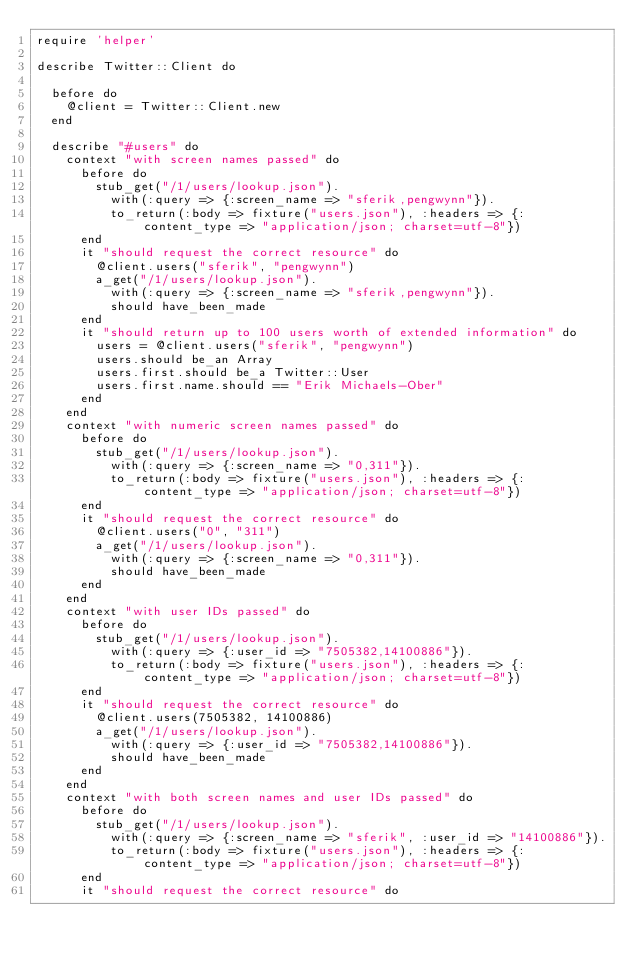<code> <loc_0><loc_0><loc_500><loc_500><_Ruby_>require 'helper'

describe Twitter::Client do

  before do
    @client = Twitter::Client.new
  end

  describe "#users" do
    context "with screen names passed" do
      before do
        stub_get("/1/users/lookup.json").
          with(:query => {:screen_name => "sferik,pengwynn"}).
          to_return(:body => fixture("users.json"), :headers => {:content_type => "application/json; charset=utf-8"})
      end
      it "should request the correct resource" do
        @client.users("sferik", "pengwynn")
        a_get("/1/users/lookup.json").
          with(:query => {:screen_name => "sferik,pengwynn"}).
          should have_been_made
      end
      it "should return up to 100 users worth of extended information" do
        users = @client.users("sferik", "pengwynn")
        users.should be_an Array
        users.first.should be_a Twitter::User
        users.first.name.should == "Erik Michaels-Ober"
      end
    end
    context "with numeric screen names passed" do
      before do
        stub_get("/1/users/lookup.json").
          with(:query => {:screen_name => "0,311"}).
          to_return(:body => fixture("users.json"), :headers => {:content_type => "application/json; charset=utf-8"})
      end
      it "should request the correct resource" do
        @client.users("0", "311")
        a_get("/1/users/lookup.json").
          with(:query => {:screen_name => "0,311"}).
          should have_been_made
      end
    end
    context "with user IDs passed" do
      before do
        stub_get("/1/users/lookup.json").
          with(:query => {:user_id => "7505382,14100886"}).
          to_return(:body => fixture("users.json"), :headers => {:content_type => "application/json; charset=utf-8"})
      end
      it "should request the correct resource" do
        @client.users(7505382, 14100886)
        a_get("/1/users/lookup.json").
          with(:query => {:user_id => "7505382,14100886"}).
          should have_been_made
      end
    end
    context "with both screen names and user IDs passed" do
      before do
        stub_get("/1/users/lookup.json").
          with(:query => {:screen_name => "sferik", :user_id => "14100886"}).
          to_return(:body => fixture("users.json"), :headers => {:content_type => "application/json; charset=utf-8"})
      end
      it "should request the correct resource" do</code> 